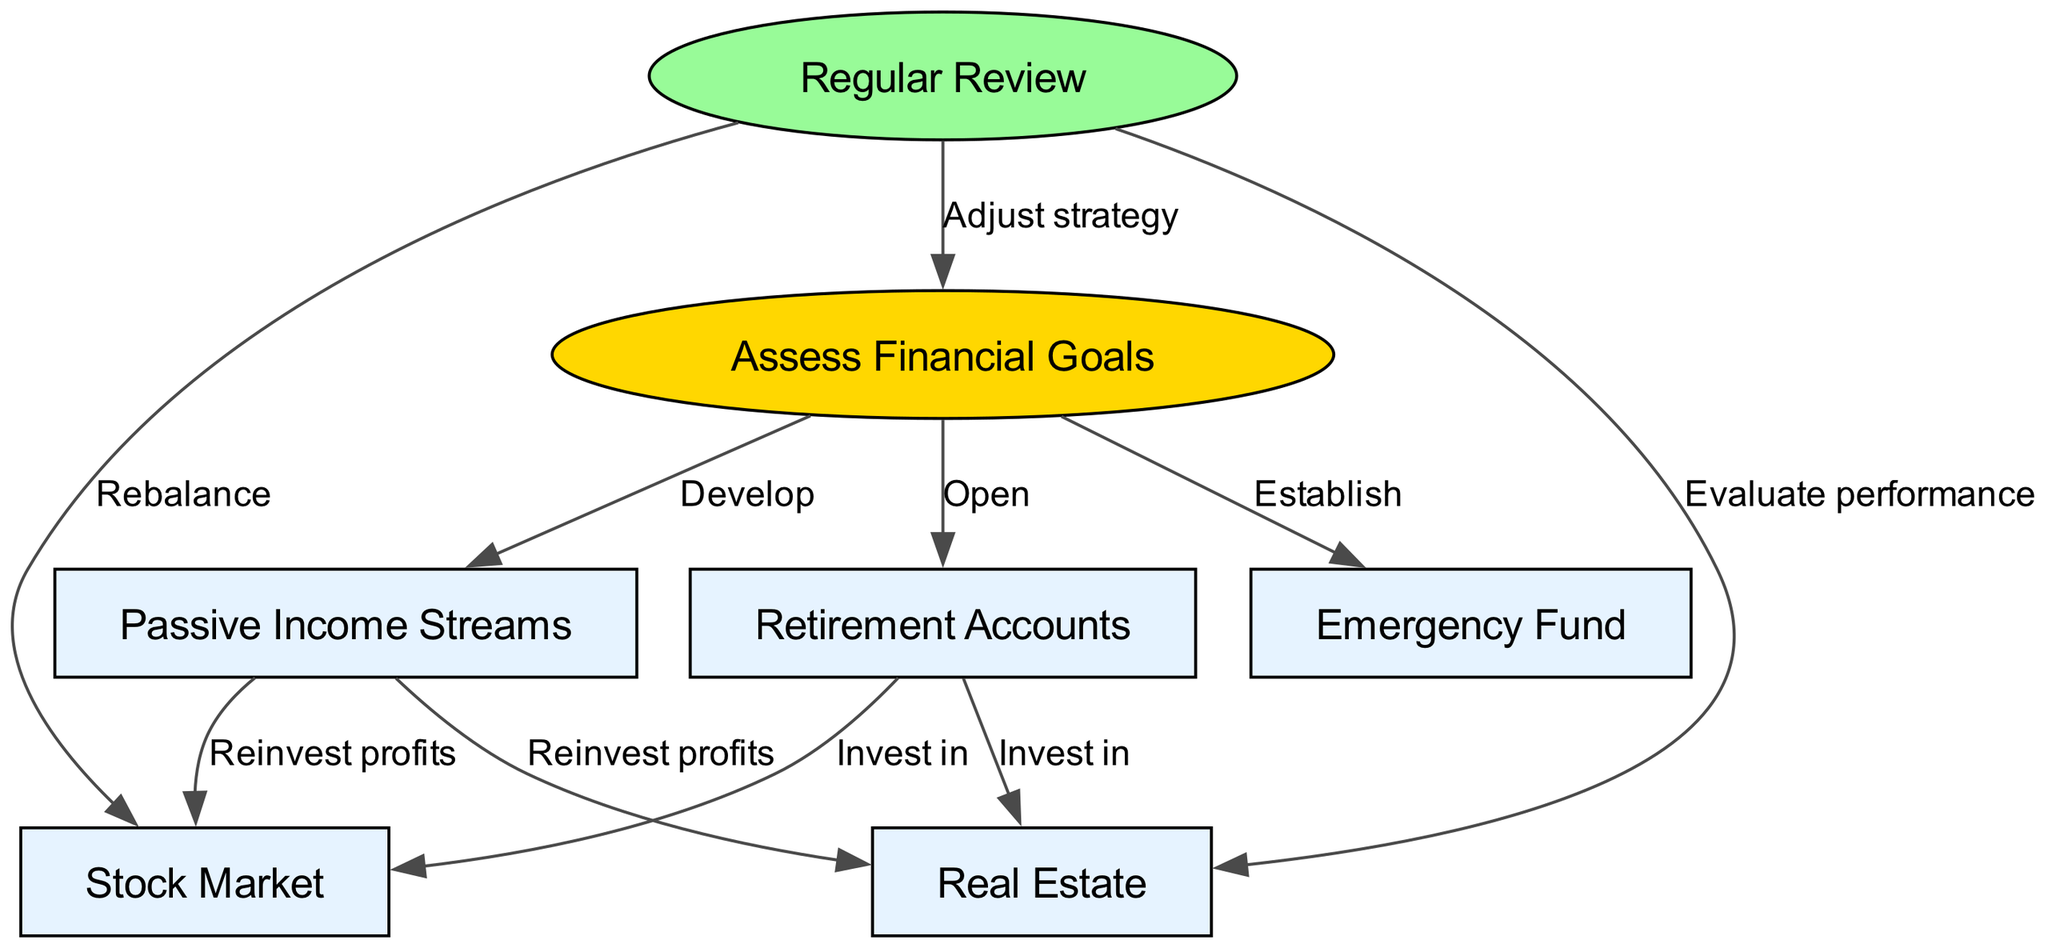What is the starting node in the diagram? The starting node in the directed graph is labeled "Assess Financial Goals" which is the first step in the investment strategy process.
Answer: Assess Financial Goals How many nodes are present in the diagram? By counting the distinct elements labeled in the diagram, there are a total of seven nodes that represent different components of the investment strategies.
Answer: 7 What type of fund is established first according to the diagram? The diagram indicates that an "Emergency Fund" is established first as part of the investment strategy flow after assessing financial goals.
Answer: Emergency Fund Which two investments are connected to "Retirement Accounts"? The edges from "Retirement Accounts" to "Stock Market" and "Real Estate" indicate that both are available investment options when utilizing retirement accounts.
Answer: Stock Market, Real Estate What term describes the action taken after Regular Review leads back to Assess Financial Goals? The edge labeled "Adjust strategy" signifies that a regular review leads to adjustments being made regarding the financial strategies in place.
Answer: Adjust strategy How do Passive Income Streams relate to Stock Market and Real Estate? According to the diagram, profits from Passive Income Streams are to be reinvested into both the Stock Market and Real Estate, thereby establishing a connection to these investments.
Answer: Reinvest profits What is the purpose of the edge connecting Regular Review to Stock Market? The connection labeled "Rebalance" indicates that after a regular review, reassessment and adjustments in the stock market investments are required for optimal performance.
Answer: Rebalance What is the overall goal of the directed graph? The diagram aims for "long-term financial security" through the establishment of various diversified investment strategies and regular assessments.
Answer: Long-term financial security 